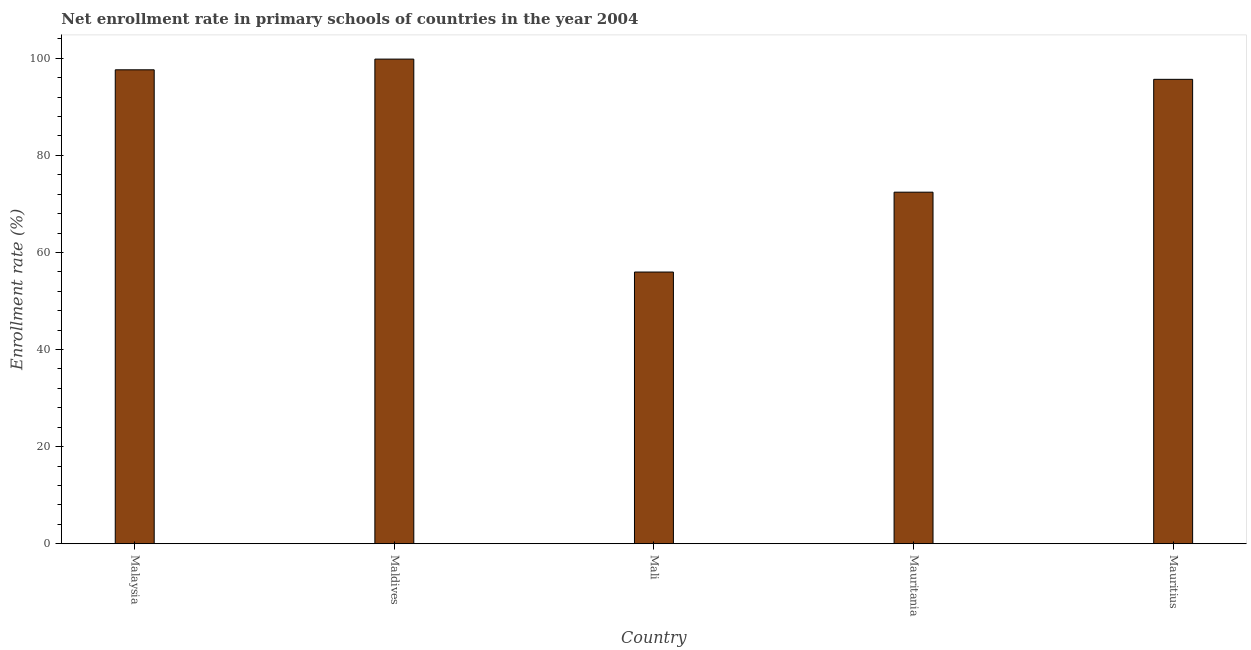Does the graph contain grids?
Keep it short and to the point. No. What is the title of the graph?
Give a very brief answer. Net enrollment rate in primary schools of countries in the year 2004. What is the label or title of the X-axis?
Offer a very short reply. Country. What is the label or title of the Y-axis?
Keep it short and to the point. Enrollment rate (%). What is the net enrollment rate in primary schools in Mali?
Offer a very short reply. 55.96. Across all countries, what is the maximum net enrollment rate in primary schools?
Your answer should be very brief. 99.82. Across all countries, what is the minimum net enrollment rate in primary schools?
Give a very brief answer. 55.96. In which country was the net enrollment rate in primary schools maximum?
Your answer should be very brief. Maldives. In which country was the net enrollment rate in primary schools minimum?
Your response must be concise. Mali. What is the sum of the net enrollment rate in primary schools?
Make the answer very short. 421.47. What is the difference between the net enrollment rate in primary schools in Mauritania and Mauritius?
Provide a short and direct response. -23.24. What is the average net enrollment rate in primary schools per country?
Provide a succinct answer. 84.3. What is the median net enrollment rate in primary schools?
Your response must be concise. 95.65. What is the ratio of the net enrollment rate in primary schools in Mauritania to that in Mauritius?
Offer a very short reply. 0.76. Is the net enrollment rate in primary schools in Mali less than that in Mauritius?
Ensure brevity in your answer.  Yes. What is the difference between the highest and the second highest net enrollment rate in primary schools?
Your answer should be very brief. 2.2. Is the sum of the net enrollment rate in primary schools in Malaysia and Maldives greater than the maximum net enrollment rate in primary schools across all countries?
Make the answer very short. Yes. What is the difference between the highest and the lowest net enrollment rate in primary schools?
Provide a short and direct response. 43.86. In how many countries, is the net enrollment rate in primary schools greater than the average net enrollment rate in primary schools taken over all countries?
Make the answer very short. 3. What is the difference between two consecutive major ticks on the Y-axis?
Your response must be concise. 20. Are the values on the major ticks of Y-axis written in scientific E-notation?
Provide a succinct answer. No. What is the Enrollment rate (%) in Malaysia?
Give a very brief answer. 97.62. What is the Enrollment rate (%) in Maldives?
Provide a succinct answer. 99.82. What is the Enrollment rate (%) of Mali?
Your response must be concise. 55.96. What is the Enrollment rate (%) in Mauritania?
Offer a very short reply. 72.41. What is the Enrollment rate (%) in Mauritius?
Ensure brevity in your answer.  95.65. What is the difference between the Enrollment rate (%) in Malaysia and Maldives?
Offer a very short reply. -2.2. What is the difference between the Enrollment rate (%) in Malaysia and Mali?
Offer a very short reply. 41.65. What is the difference between the Enrollment rate (%) in Malaysia and Mauritania?
Make the answer very short. 25.2. What is the difference between the Enrollment rate (%) in Malaysia and Mauritius?
Keep it short and to the point. 1.96. What is the difference between the Enrollment rate (%) in Maldives and Mali?
Your answer should be very brief. 43.86. What is the difference between the Enrollment rate (%) in Maldives and Mauritania?
Offer a terse response. 27.41. What is the difference between the Enrollment rate (%) in Maldives and Mauritius?
Your response must be concise. 4.17. What is the difference between the Enrollment rate (%) in Mali and Mauritania?
Offer a very short reply. -16.45. What is the difference between the Enrollment rate (%) in Mali and Mauritius?
Give a very brief answer. -39.69. What is the difference between the Enrollment rate (%) in Mauritania and Mauritius?
Provide a succinct answer. -23.24. What is the ratio of the Enrollment rate (%) in Malaysia to that in Maldives?
Make the answer very short. 0.98. What is the ratio of the Enrollment rate (%) in Malaysia to that in Mali?
Your answer should be compact. 1.74. What is the ratio of the Enrollment rate (%) in Malaysia to that in Mauritania?
Provide a short and direct response. 1.35. What is the ratio of the Enrollment rate (%) in Maldives to that in Mali?
Your answer should be compact. 1.78. What is the ratio of the Enrollment rate (%) in Maldives to that in Mauritania?
Your answer should be very brief. 1.38. What is the ratio of the Enrollment rate (%) in Maldives to that in Mauritius?
Provide a short and direct response. 1.04. What is the ratio of the Enrollment rate (%) in Mali to that in Mauritania?
Keep it short and to the point. 0.77. What is the ratio of the Enrollment rate (%) in Mali to that in Mauritius?
Your answer should be compact. 0.58. What is the ratio of the Enrollment rate (%) in Mauritania to that in Mauritius?
Your answer should be very brief. 0.76. 